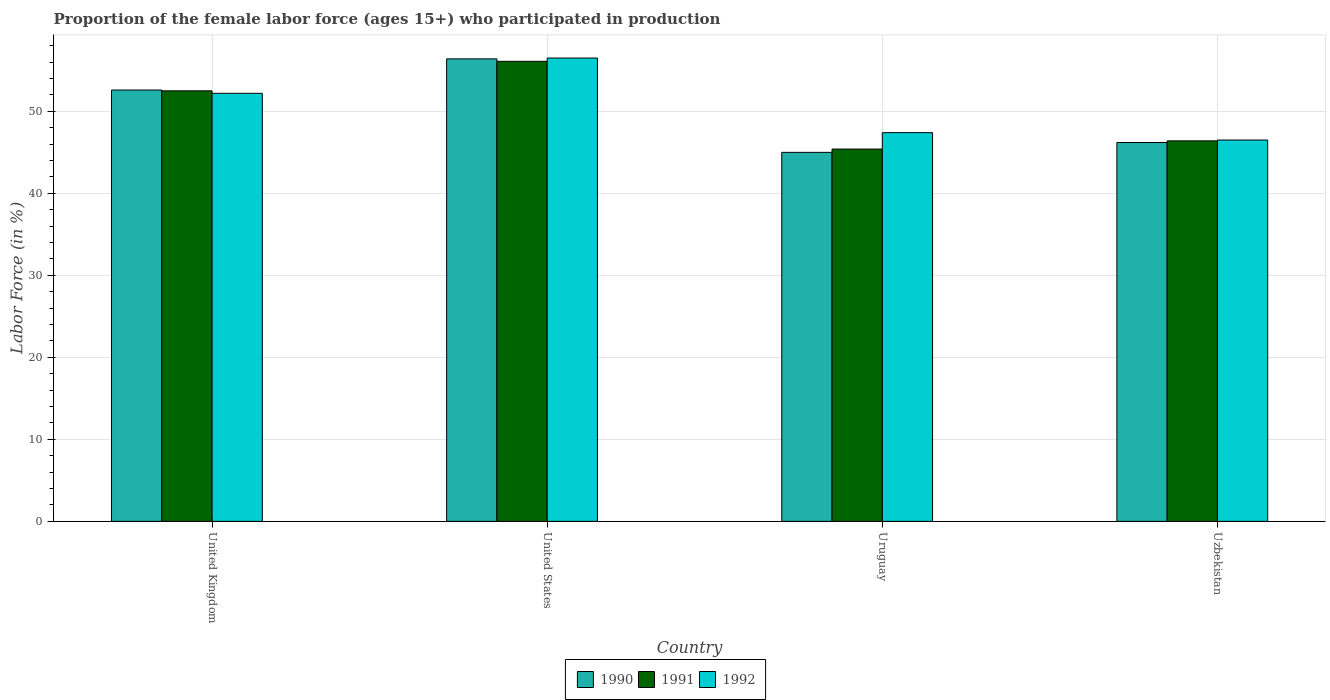How many groups of bars are there?
Provide a short and direct response. 4. Are the number of bars per tick equal to the number of legend labels?
Provide a short and direct response. Yes. How many bars are there on the 4th tick from the left?
Your answer should be very brief. 3. What is the label of the 3rd group of bars from the left?
Keep it short and to the point. Uruguay. What is the proportion of the female labor force who participated in production in 1991 in Uruguay?
Offer a terse response. 45.4. Across all countries, what is the maximum proportion of the female labor force who participated in production in 1990?
Keep it short and to the point. 56.4. In which country was the proportion of the female labor force who participated in production in 1991 maximum?
Your answer should be compact. United States. In which country was the proportion of the female labor force who participated in production in 1991 minimum?
Provide a short and direct response. Uruguay. What is the total proportion of the female labor force who participated in production in 1991 in the graph?
Provide a short and direct response. 200.4. What is the difference between the proportion of the female labor force who participated in production in 1992 in United States and that in Uruguay?
Make the answer very short. 9.1. What is the difference between the proportion of the female labor force who participated in production in 1990 in Uzbekistan and the proportion of the female labor force who participated in production in 1992 in United States?
Offer a terse response. -10.3. What is the average proportion of the female labor force who participated in production in 1991 per country?
Your response must be concise. 50.1. What is the difference between the proportion of the female labor force who participated in production of/in 1992 and proportion of the female labor force who participated in production of/in 1990 in Uruguay?
Give a very brief answer. 2.4. What is the ratio of the proportion of the female labor force who participated in production in 1990 in United States to that in Uruguay?
Make the answer very short. 1.25. What is the difference between the highest and the second highest proportion of the female labor force who participated in production in 1991?
Your answer should be compact. 3.6. What is the difference between the highest and the lowest proportion of the female labor force who participated in production in 1992?
Offer a terse response. 10. Is the sum of the proportion of the female labor force who participated in production in 1992 in United Kingdom and United States greater than the maximum proportion of the female labor force who participated in production in 1991 across all countries?
Offer a terse response. Yes. What does the 1st bar from the left in United States represents?
Make the answer very short. 1990. Are all the bars in the graph horizontal?
Give a very brief answer. No. Does the graph contain any zero values?
Your answer should be compact. No. How are the legend labels stacked?
Make the answer very short. Horizontal. What is the title of the graph?
Keep it short and to the point. Proportion of the female labor force (ages 15+) who participated in production. Does "2008" appear as one of the legend labels in the graph?
Offer a very short reply. No. What is the Labor Force (in %) of 1990 in United Kingdom?
Your answer should be compact. 52.6. What is the Labor Force (in %) of 1991 in United Kingdom?
Make the answer very short. 52.5. What is the Labor Force (in %) of 1992 in United Kingdom?
Offer a very short reply. 52.2. What is the Labor Force (in %) in 1990 in United States?
Keep it short and to the point. 56.4. What is the Labor Force (in %) in 1991 in United States?
Provide a short and direct response. 56.1. What is the Labor Force (in %) in 1992 in United States?
Your response must be concise. 56.5. What is the Labor Force (in %) of 1991 in Uruguay?
Your answer should be very brief. 45.4. What is the Labor Force (in %) of 1992 in Uruguay?
Ensure brevity in your answer.  47.4. What is the Labor Force (in %) in 1990 in Uzbekistan?
Provide a succinct answer. 46.2. What is the Labor Force (in %) of 1991 in Uzbekistan?
Provide a short and direct response. 46.4. What is the Labor Force (in %) of 1992 in Uzbekistan?
Provide a succinct answer. 46.5. Across all countries, what is the maximum Labor Force (in %) of 1990?
Provide a short and direct response. 56.4. Across all countries, what is the maximum Labor Force (in %) of 1991?
Make the answer very short. 56.1. Across all countries, what is the maximum Labor Force (in %) in 1992?
Your answer should be compact. 56.5. Across all countries, what is the minimum Labor Force (in %) of 1990?
Give a very brief answer. 45. Across all countries, what is the minimum Labor Force (in %) in 1991?
Ensure brevity in your answer.  45.4. Across all countries, what is the minimum Labor Force (in %) in 1992?
Offer a terse response. 46.5. What is the total Labor Force (in %) in 1990 in the graph?
Offer a terse response. 200.2. What is the total Labor Force (in %) of 1991 in the graph?
Your answer should be compact. 200.4. What is the total Labor Force (in %) in 1992 in the graph?
Offer a very short reply. 202.6. What is the difference between the Labor Force (in %) of 1991 in United Kingdom and that in United States?
Offer a very short reply. -3.6. What is the difference between the Labor Force (in %) in 1992 in United Kingdom and that in United States?
Provide a succinct answer. -4.3. What is the difference between the Labor Force (in %) of 1990 in United Kingdom and that in Uruguay?
Give a very brief answer. 7.6. What is the difference between the Labor Force (in %) in 1991 in United Kingdom and that in Uruguay?
Keep it short and to the point. 7.1. What is the difference between the Labor Force (in %) in 1992 in United Kingdom and that in Uruguay?
Offer a terse response. 4.8. What is the difference between the Labor Force (in %) in 1990 in United Kingdom and that in Uzbekistan?
Keep it short and to the point. 6.4. What is the difference between the Labor Force (in %) of 1991 in United Kingdom and that in Uzbekistan?
Provide a succinct answer. 6.1. What is the difference between the Labor Force (in %) in 1992 in United Kingdom and that in Uzbekistan?
Provide a succinct answer. 5.7. What is the difference between the Labor Force (in %) of 1990 in United States and that in Uruguay?
Your answer should be very brief. 11.4. What is the difference between the Labor Force (in %) in 1990 in United States and that in Uzbekistan?
Make the answer very short. 10.2. What is the difference between the Labor Force (in %) of 1991 in United States and that in Uzbekistan?
Make the answer very short. 9.7. What is the difference between the Labor Force (in %) in 1992 in United States and that in Uzbekistan?
Provide a short and direct response. 10. What is the difference between the Labor Force (in %) of 1990 in Uruguay and that in Uzbekistan?
Your response must be concise. -1.2. What is the difference between the Labor Force (in %) of 1991 in Uruguay and that in Uzbekistan?
Your response must be concise. -1. What is the difference between the Labor Force (in %) in 1992 in Uruguay and that in Uzbekistan?
Provide a short and direct response. 0.9. What is the difference between the Labor Force (in %) in 1990 in United Kingdom and the Labor Force (in %) in 1991 in United States?
Make the answer very short. -3.5. What is the difference between the Labor Force (in %) of 1990 in United Kingdom and the Labor Force (in %) of 1991 in Uruguay?
Offer a terse response. 7.2. What is the difference between the Labor Force (in %) of 1991 in United Kingdom and the Labor Force (in %) of 1992 in Uruguay?
Keep it short and to the point. 5.1. What is the difference between the Labor Force (in %) in 1990 in United Kingdom and the Labor Force (in %) in 1991 in Uzbekistan?
Provide a succinct answer. 6.2. What is the difference between the Labor Force (in %) of 1991 in United Kingdom and the Labor Force (in %) of 1992 in Uzbekistan?
Your answer should be compact. 6. What is the difference between the Labor Force (in %) of 1990 in United States and the Labor Force (in %) of 1991 in Uruguay?
Keep it short and to the point. 11. What is the difference between the Labor Force (in %) of 1991 in United States and the Labor Force (in %) of 1992 in Uruguay?
Give a very brief answer. 8.7. What is the difference between the Labor Force (in %) in 1990 in United States and the Labor Force (in %) in 1991 in Uzbekistan?
Your answer should be very brief. 10. What is the difference between the Labor Force (in %) in 1991 in United States and the Labor Force (in %) in 1992 in Uzbekistan?
Keep it short and to the point. 9.6. What is the difference between the Labor Force (in %) of 1990 in Uruguay and the Labor Force (in %) of 1991 in Uzbekistan?
Your answer should be very brief. -1.4. What is the average Labor Force (in %) in 1990 per country?
Provide a short and direct response. 50.05. What is the average Labor Force (in %) of 1991 per country?
Make the answer very short. 50.1. What is the average Labor Force (in %) of 1992 per country?
Ensure brevity in your answer.  50.65. What is the difference between the Labor Force (in %) of 1991 and Labor Force (in %) of 1992 in United Kingdom?
Give a very brief answer. 0.3. What is the difference between the Labor Force (in %) of 1990 and Labor Force (in %) of 1991 in United States?
Offer a terse response. 0.3. What is the difference between the Labor Force (in %) of 1991 and Labor Force (in %) of 1992 in United States?
Ensure brevity in your answer.  -0.4. What is the difference between the Labor Force (in %) of 1990 and Labor Force (in %) of 1991 in Uruguay?
Your answer should be compact. -0.4. What is the difference between the Labor Force (in %) in 1990 and Labor Force (in %) in 1992 in Uruguay?
Your answer should be very brief. -2.4. What is the difference between the Labor Force (in %) of 1990 and Labor Force (in %) of 1991 in Uzbekistan?
Keep it short and to the point. -0.2. What is the ratio of the Labor Force (in %) in 1990 in United Kingdom to that in United States?
Make the answer very short. 0.93. What is the ratio of the Labor Force (in %) of 1991 in United Kingdom to that in United States?
Offer a terse response. 0.94. What is the ratio of the Labor Force (in %) of 1992 in United Kingdom to that in United States?
Your response must be concise. 0.92. What is the ratio of the Labor Force (in %) in 1990 in United Kingdom to that in Uruguay?
Your answer should be very brief. 1.17. What is the ratio of the Labor Force (in %) of 1991 in United Kingdom to that in Uruguay?
Offer a terse response. 1.16. What is the ratio of the Labor Force (in %) of 1992 in United Kingdom to that in Uruguay?
Offer a very short reply. 1.1. What is the ratio of the Labor Force (in %) of 1990 in United Kingdom to that in Uzbekistan?
Your response must be concise. 1.14. What is the ratio of the Labor Force (in %) in 1991 in United Kingdom to that in Uzbekistan?
Your answer should be compact. 1.13. What is the ratio of the Labor Force (in %) in 1992 in United Kingdom to that in Uzbekistan?
Your answer should be compact. 1.12. What is the ratio of the Labor Force (in %) of 1990 in United States to that in Uruguay?
Offer a very short reply. 1.25. What is the ratio of the Labor Force (in %) in 1991 in United States to that in Uruguay?
Provide a succinct answer. 1.24. What is the ratio of the Labor Force (in %) of 1992 in United States to that in Uruguay?
Your answer should be compact. 1.19. What is the ratio of the Labor Force (in %) in 1990 in United States to that in Uzbekistan?
Offer a very short reply. 1.22. What is the ratio of the Labor Force (in %) of 1991 in United States to that in Uzbekistan?
Give a very brief answer. 1.21. What is the ratio of the Labor Force (in %) in 1992 in United States to that in Uzbekistan?
Your answer should be compact. 1.22. What is the ratio of the Labor Force (in %) in 1990 in Uruguay to that in Uzbekistan?
Keep it short and to the point. 0.97. What is the ratio of the Labor Force (in %) in 1991 in Uruguay to that in Uzbekistan?
Your answer should be compact. 0.98. What is the ratio of the Labor Force (in %) of 1992 in Uruguay to that in Uzbekistan?
Keep it short and to the point. 1.02. What is the difference between the highest and the second highest Labor Force (in %) in 1990?
Keep it short and to the point. 3.8. What is the difference between the highest and the lowest Labor Force (in %) in 1990?
Offer a very short reply. 11.4. What is the difference between the highest and the lowest Labor Force (in %) of 1991?
Your answer should be very brief. 10.7. What is the difference between the highest and the lowest Labor Force (in %) of 1992?
Your answer should be very brief. 10. 